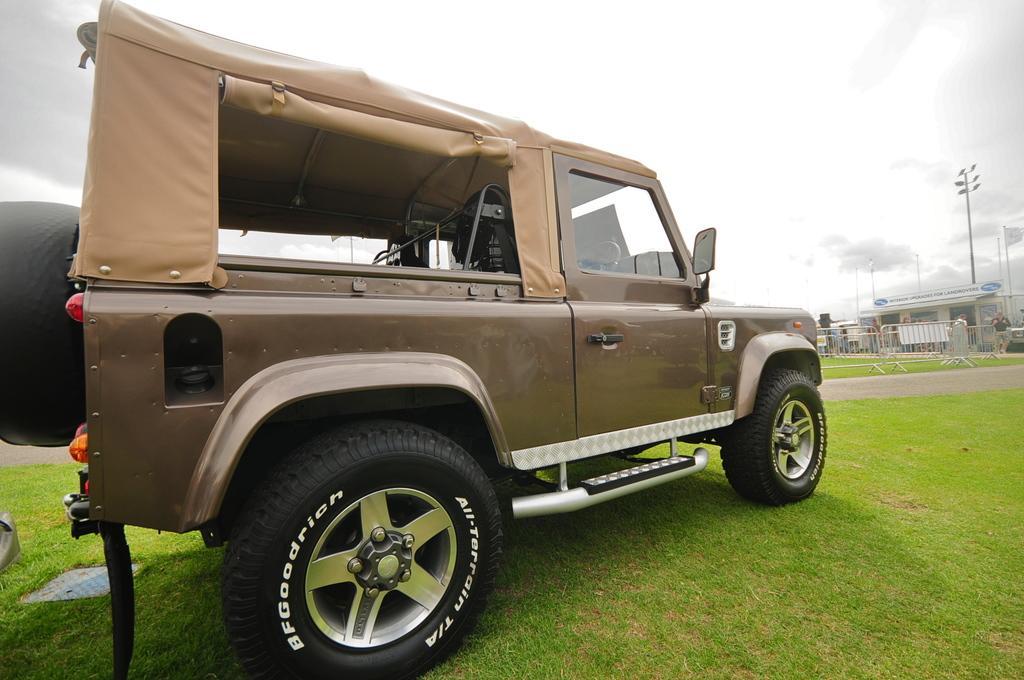Describe this image in one or two sentences. In the picture we can see a jeep which is light brown in color parked on the grass surface and in front of the jeep we can see a path and behind it also we can see a grass surface with railing and behind it, we can see some people are standing and near the house and behind it we can see some poles with lights and sky with clouds. 